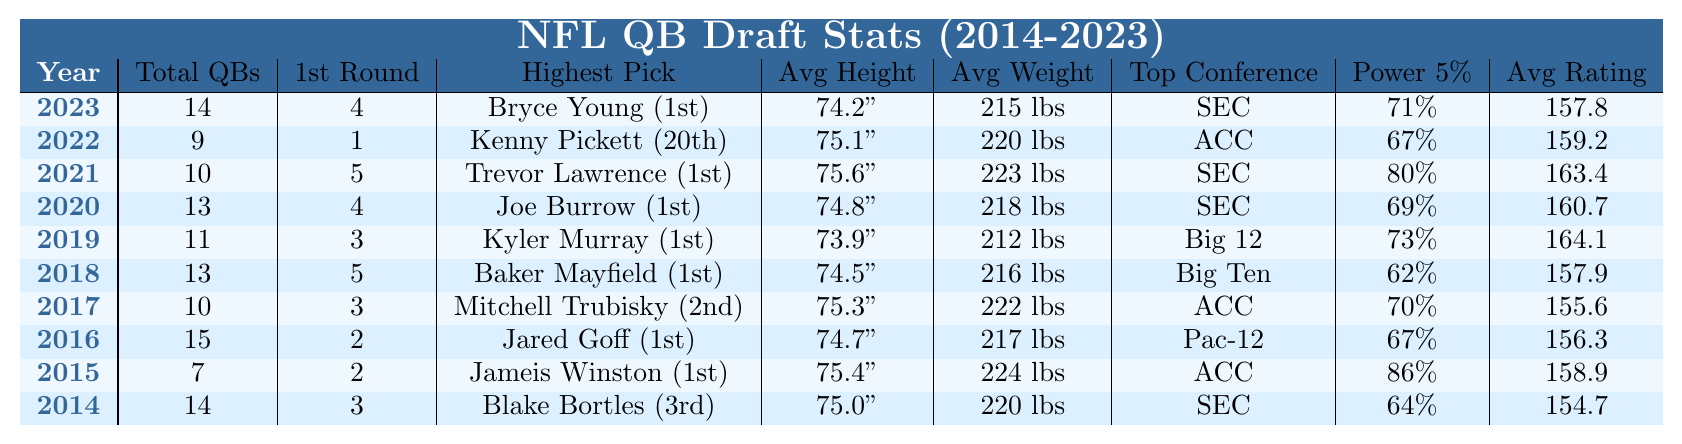What year had the highest average height for QBs drafted? To find the year with the highest average height, we review the "Avg. Height" column. The tallest average height is 75.6 inches in 2021.
Answer: 2021 How many total quarterbacks were drafted in 2020? The total number of quarterbacks drafted in 2020 is directly listed in the "Total QBs Drafted" column, which shows 13 for that year.
Answer: 13 Which college conference had the most QBs drafted from the Power 5 in 2015? Looking at the "Top College Conference" and "% from Power 5" for 2015, it indicates that the ACC had 86% representation.
Answer: Yes What is the average weight of quarterbacks drafted in the last two years (2022 and 2023)? The average weight can be calculated by taking the weights from those years: (220 lbs in 2022 + 215 lbs in 2023) / 2 = 217.5 lbs.
Answer: 217.5 lbs Which year had the lowest number of first-round quarterbacks? We check the "1st Round QBs" column for each year, where 1st round quarterbacks drafted is lowest in 2022 with only 1 drafted.
Answer: 2022 In how many years were more than 10 quarterbacks drafted? By reviewing the "Total QBs Drafted" column, we can see that in 2023, 2020, 2018, and 2016, more than 10 quarterbacks were drafted, making it 4 years.
Answer: 4 What was the highest passer rating achieved by a quarterback in the past 10 years? By checking the "Avg. Collegiate Passer Rating," we find the highest rating is 164.1 in 2019.
Answer: 164.1 Did the SEC consistently have the highest average height for QBs drafted from 2014 to 2023? We need to compare the average heights from different years and find that for the years 2019, 2021, and 2023, SEC strived for high average heights while not consistently the highest every year. The highest was in 2021, but 2022 was not SEC related, so the statement is false.
Answer: No What is the difference between the average height of the quarterbacks drafted in 2021 and 2018? From the "Avg. Height" column, we see 75.6 inches in 2021 and 74.5 inches in 2018. The difference is 75.6 - 74.5 = 1.1 inches.
Answer: 1.1 inches Which year had the highest total number of quarterbacks drafted from the SEC? We can observe the "Total QBs Drafted" alongside the "Top College Conference" column. The highest SEC total is 14 in 2023.
Answer: 2023 